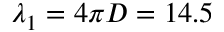Convert formula to latex. <formula><loc_0><loc_0><loc_500><loc_500>\lambda _ { 1 } = 4 \pi D = 1 4 . 5</formula> 